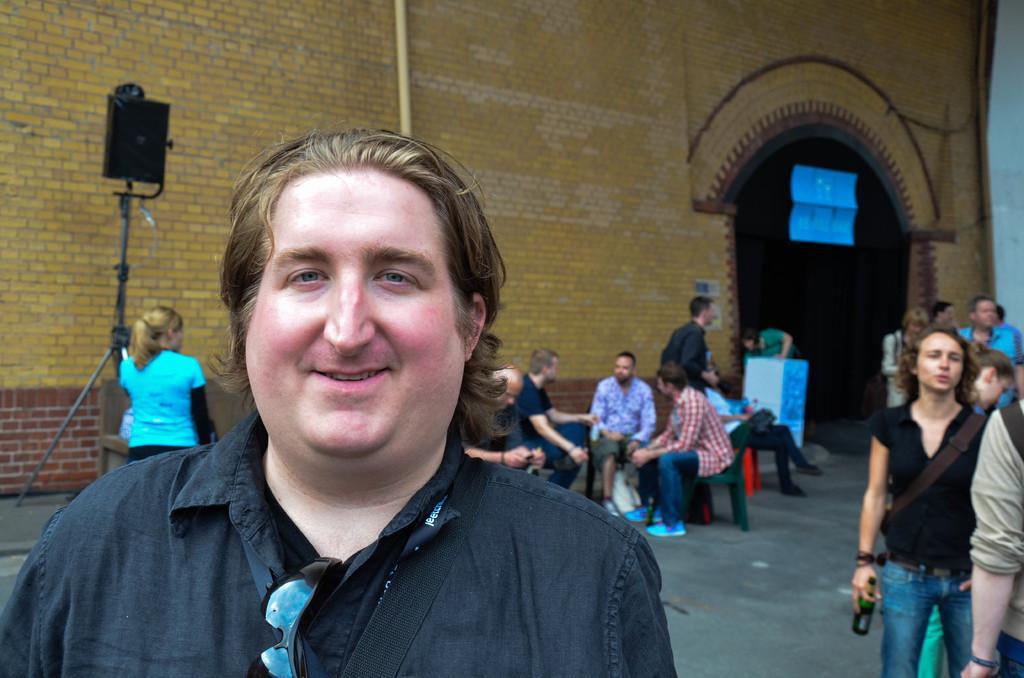Could you give a brief overview of what you see in this image? In the foreground of this image, there is a man and also we can see a spectacle to his shirt. Behind him, there are few people standing and few are sitting on the chairs. On the right, there is a person standing and holding a bottle. On the left, there is a woman standing. In the background, there is a wall, a speaker like an object to the stand, an arch and a person near a podium. 